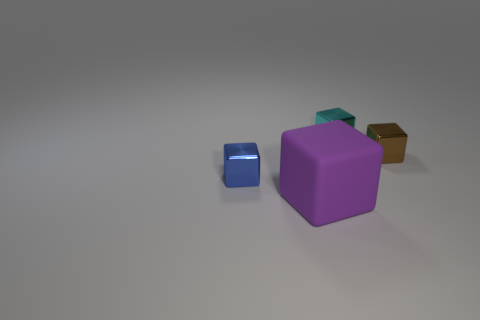Is there any other thing that is the same size as the purple block? In the displayed image, no object exactly matches the size of the purple block. The blue block is significantly smaller, while the teal and brown blocks appear to be slightly smaller than the purple block but larger than the blue one. 